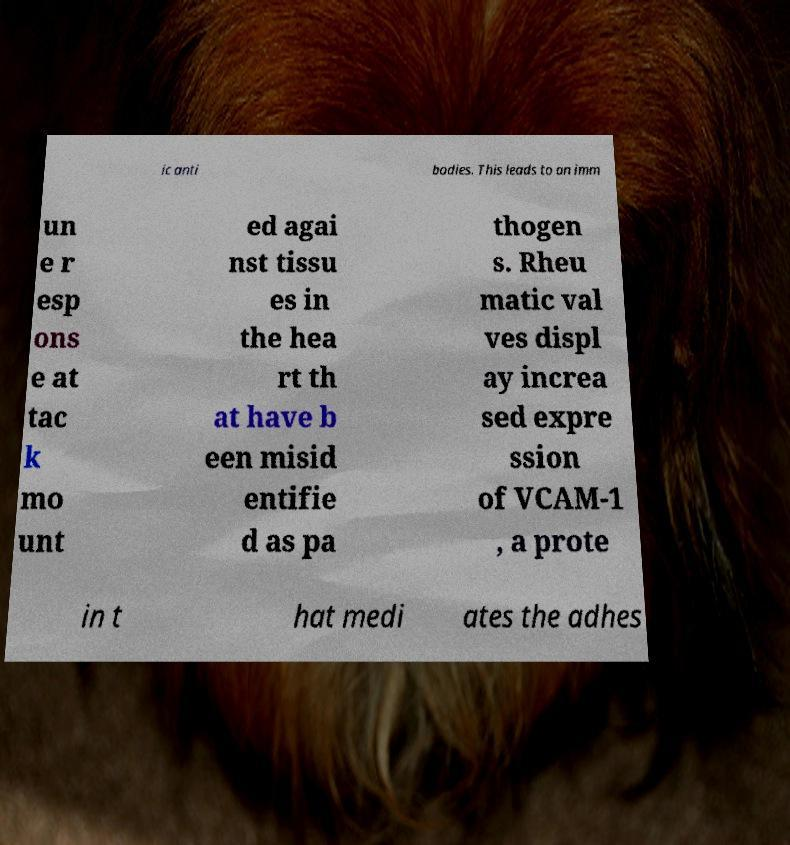For documentation purposes, I need the text within this image transcribed. Could you provide that? ic anti bodies. This leads to an imm un e r esp ons e at tac k mo unt ed agai nst tissu es in the hea rt th at have b een misid entifie d as pa thogen s. Rheu matic val ves displ ay increa sed expre ssion of VCAM-1 , a prote in t hat medi ates the adhes 